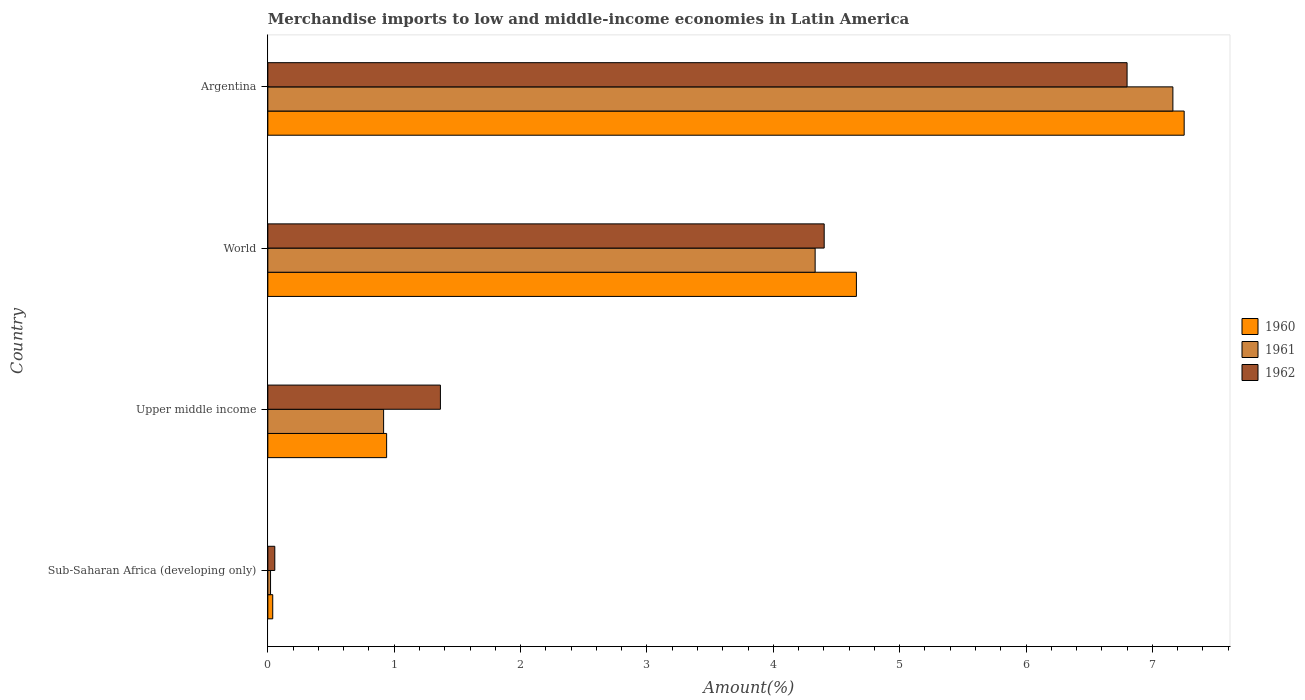How many groups of bars are there?
Offer a terse response. 4. Are the number of bars per tick equal to the number of legend labels?
Make the answer very short. Yes. How many bars are there on the 3rd tick from the top?
Provide a succinct answer. 3. What is the label of the 1st group of bars from the top?
Your answer should be very brief. Argentina. In how many cases, is the number of bars for a given country not equal to the number of legend labels?
Give a very brief answer. 0. What is the percentage of amount earned from merchandise imports in 1961 in Sub-Saharan Africa (developing only)?
Make the answer very short. 0.02. Across all countries, what is the maximum percentage of amount earned from merchandise imports in 1960?
Your answer should be very brief. 7.25. Across all countries, what is the minimum percentage of amount earned from merchandise imports in 1960?
Offer a terse response. 0.04. In which country was the percentage of amount earned from merchandise imports in 1961 maximum?
Provide a succinct answer. Argentina. In which country was the percentage of amount earned from merchandise imports in 1960 minimum?
Your answer should be compact. Sub-Saharan Africa (developing only). What is the total percentage of amount earned from merchandise imports in 1960 in the graph?
Give a very brief answer. 12.89. What is the difference between the percentage of amount earned from merchandise imports in 1960 in Sub-Saharan Africa (developing only) and that in Upper middle income?
Provide a succinct answer. -0.9. What is the difference between the percentage of amount earned from merchandise imports in 1962 in Argentina and the percentage of amount earned from merchandise imports in 1961 in Sub-Saharan Africa (developing only)?
Keep it short and to the point. 6.78. What is the average percentage of amount earned from merchandise imports in 1961 per country?
Your response must be concise. 3.11. What is the difference between the percentage of amount earned from merchandise imports in 1961 and percentage of amount earned from merchandise imports in 1962 in Upper middle income?
Provide a short and direct response. -0.45. In how many countries, is the percentage of amount earned from merchandise imports in 1961 greater than 1.2 %?
Offer a terse response. 2. What is the ratio of the percentage of amount earned from merchandise imports in 1961 in Sub-Saharan Africa (developing only) to that in Upper middle income?
Provide a succinct answer. 0.02. Is the difference between the percentage of amount earned from merchandise imports in 1961 in Argentina and World greater than the difference between the percentage of amount earned from merchandise imports in 1962 in Argentina and World?
Provide a short and direct response. Yes. What is the difference between the highest and the second highest percentage of amount earned from merchandise imports in 1961?
Your answer should be very brief. 2.83. What is the difference between the highest and the lowest percentage of amount earned from merchandise imports in 1962?
Offer a terse response. 6.74. In how many countries, is the percentage of amount earned from merchandise imports in 1962 greater than the average percentage of amount earned from merchandise imports in 1962 taken over all countries?
Give a very brief answer. 2. What does the 3rd bar from the bottom in Argentina represents?
Provide a succinct answer. 1962. How many bars are there?
Make the answer very short. 12. How many countries are there in the graph?
Your answer should be very brief. 4. What is the difference between two consecutive major ticks on the X-axis?
Your answer should be compact. 1. Does the graph contain grids?
Make the answer very short. No. How many legend labels are there?
Your answer should be very brief. 3. How are the legend labels stacked?
Your answer should be compact. Vertical. What is the title of the graph?
Make the answer very short. Merchandise imports to low and middle-income economies in Latin America. What is the label or title of the X-axis?
Your answer should be very brief. Amount(%). What is the label or title of the Y-axis?
Give a very brief answer. Country. What is the Amount(%) of 1960 in Sub-Saharan Africa (developing only)?
Keep it short and to the point. 0.04. What is the Amount(%) of 1961 in Sub-Saharan Africa (developing only)?
Ensure brevity in your answer.  0.02. What is the Amount(%) in 1962 in Sub-Saharan Africa (developing only)?
Your answer should be very brief. 0.06. What is the Amount(%) in 1960 in Upper middle income?
Keep it short and to the point. 0.94. What is the Amount(%) in 1961 in Upper middle income?
Offer a very short reply. 0.92. What is the Amount(%) in 1962 in Upper middle income?
Your response must be concise. 1.37. What is the Amount(%) in 1960 in World?
Provide a short and direct response. 4.66. What is the Amount(%) of 1961 in World?
Provide a short and direct response. 4.33. What is the Amount(%) of 1962 in World?
Provide a short and direct response. 4.4. What is the Amount(%) in 1960 in Argentina?
Provide a short and direct response. 7.25. What is the Amount(%) in 1961 in Argentina?
Give a very brief answer. 7.16. What is the Amount(%) of 1962 in Argentina?
Provide a short and direct response. 6.8. Across all countries, what is the maximum Amount(%) in 1960?
Ensure brevity in your answer.  7.25. Across all countries, what is the maximum Amount(%) of 1961?
Ensure brevity in your answer.  7.16. Across all countries, what is the maximum Amount(%) in 1962?
Your response must be concise. 6.8. Across all countries, what is the minimum Amount(%) of 1960?
Offer a very short reply. 0.04. Across all countries, what is the minimum Amount(%) in 1961?
Ensure brevity in your answer.  0.02. Across all countries, what is the minimum Amount(%) in 1962?
Provide a succinct answer. 0.06. What is the total Amount(%) in 1960 in the graph?
Give a very brief answer. 12.89. What is the total Amount(%) of 1961 in the graph?
Offer a very short reply. 12.43. What is the total Amount(%) in 1962 in the graph?
Your answer should be very brief. 12.62. What is the difference between the Amount(%) of 1960 in Sub-Saharan Africa (developing only) and that in Upper middle income?
Provide a short and direct response. -0.9. What is the difference between the Amount(%) in 1961 in Sub-Saharan Africa (developing only) and that in Upper middle income?
Provide a succinct answer. -0.89. What is the difference between the Amount(%) of 1962 in Sub-Saharan Africa (developing only) and that in Upper middle income?
Your response must be concise. -1.31. What is the difference between the Amount(%) in 1960 in Sub-Saharan Africa (developing only) and that in World?
Your answer should be very brief. -4.62. What is the difference between the Amount(%) of 1961 in Sub-Saharan Africa (developing only) and that in World?
Your answer should be very brief. -4.31. What is the difference between the Amount(%) in 1962 in Sub-Saharan Africa (developing only) and that in World?
Your answer should be very brief. -4.35. What is the difference between the Amount(%) in 1960 in Sub-Saharan Africa (developing only) and that in Argentina?
Give a very brief answer. -7.21. What is the difference between the Amount(%) of 1961 in Sub-Saharan Africa (developing only) and that in Argentina?
Make the answer very short. -7.14. What is the difference between the Amount(%) in 1962 in Sub-Saharan Africa (developing only) and that in Argentina?
Offer a very short reply. -6.74. What is the difference between the Amount(%) in 1960 in Upper middle income and that in World?
Keep it short and to the point. -3.72. What is the difference between the Amount(%) in 1961 in Upper middle income and that in World?
Your answer should be compact. -3.42. What is the difference between the Amount(%) of 1962 in Upper middle income and that in World?
Offer a terse response. -3.04. What is the difference between the Amount(%) in 1960 in Upper middle income and that in Argentina?
Provide a short and direct response. -6.31. What is the difference between the Amount(%) of 1961 in Upper middle income and that in Argentina?
Ensure brevity in your answer.  -6.25. What is the difference between the Amount(%) of 1962 in Upper middle income and that in Argentina?
Offer a terse response. -5.43. What is the difference between the Amount(%) in 1960 in World and that in Argentina?
Provide a succinct answer. -2.59. What is the difference between the Amount(%) in 1961 in World and that in Argentina?
Your response must be concise. -2.83. What is the difference between the Amount(%) of 1962 in World and that in Argentina?
Keep it short and to the point. -2.4. What is the difference between the Amount(%) of 1960 in Sub-Saharan Africa (developing only) and the Amount(%) of 1961 in Upper middle income?
Make the answer very short. -0.88. What is the difference between the Amount(%) in 1960 in Sub-Saharan Africa (developing only) and the Amount(%) in 1962 in Upper middle income?
Give a very brief answer. -1.33. What is the difference between the Amount(%) in 1961 in Sub-Saharan Africa (developing only) and the Amount(%) in 1962 in Upper middle income?
Offer a terse response. -1.34. What is the difference between the Amount(%) in 1960 in Sub-Saharan Africa (developing only) and the Amount(%) in 1961 in World?
Give a very brief answer. -4.29. What is the difference between the Amount(%) of 1960 in Sub-Saharan Africa (developing only) and the Amount(%) of 1962 in World?
Your response must be concise. -4.36. What is the difference between the Amount(%) in 1961 in Sub-Saharan Africa (developing only) and the Amount(%) in 1962 in World?
Give a very brief answer. -4.38. What is the difference between the Amount(%) of 1960 in Sub-Saharan Africa (developing only) and the Amount(%) of 1961 in Argentina?
Your response must be concise. -7.12. What is the difference between the Amount(%) in 1960 in Sub-Saharan Africa (developing only) and the Amount(%) in 1962 in Argentina?
Offer a very short reply. -6.76. What is the difference between the Amount(%) of 1961 in Sub-Saharan Africa (developing only) and the Amount(%) of 1962 in Argentina?
Provide a succinct answer. -6.78. What is the difference between the Amount(%) of 1960 in Upper middle income and the Amount(%) of 1961 in World?
Offer a terse response. -3.39. What is the difference between the Amount(%) of 1960 in Upper middle income and the Amount(%) of 1962 in World?
Keep it short and to the point. -3.46. What is the difference between the Amount(%) of 1961 in Upper middle income and the Amount(%) of 1962 in World?
Offer a very short reply. -3.49. What is the difference between the Amount(%) of 1960 in Upper middle income and the Amount(%) of 1961 in Argentina?
Your answer should be compact. -6.22. What is the difference between the Amount(%) of 1960 in Upper middle income and the Amount(%) of 1962 in Argentina?
Make the answer very short. -5.86. What is the difference between the Amount(%) in 1961 in Upper middle income and the Amount(%) in 1962 in Argentina?
Provide a succinct answer. -5.88. What is the difference between the Amount(%) of 1960 in World and the Amount(%) of 1961 in Argentina?
Your response must be concise. -2.5. What is the difference between the Amount(%) of 1960 in World and the Amount(%) of 1962 in Argentina?
Provide a succinct answer. -2.14. What is the difference between the Amount(%) in 1961 in World and the Amount(%) in 1962 in Argentina?
Provide a succinct answer. -2.47. What is the average Amount(%) in 1960 per country?
Give a very brief answer. 3.22. What is the average Amount(%) in 1961 per country?
Ensure brevity in your answer.  3.11. What is the average Amount(%) in 1962 per country?
Provide a succinct answer. 3.16. What is the difference between the Amount(%) of 1960 and Amount(%) of 1961 in Sub-Saharan Africa (developing only)?
Offer a terse response. 0.02. What is the difference between the Amount(%) of 1960 and Amount(%) of 1962 in Sub-Saharan Africa (developing only)?
Provide a short and direct response. -0.02. What is the difference between the Amount(%) of 1961 and Amount(%) of 1962 in Sub-Saharan Africa (developing only)?
Provide a succinct answer. -0.03. What is the difference between the Amount(%) of 1960 and Amount(%) of 1961 in Upper middle income?
Ensure brevity in your answer.  0.02. What is the difference between the Amount(%) in 1960 and Amount(%) in 1962 in Upper middle income?
Make the answer very short. -0.43. What is the difference between the Amount(%) in 1961 and Amount(%) in 1962 in Upper middle income?
Your answer should be compact. -0.45. What is the difference between the Amount(%) of 1960 and Amount(%) of 1961 in World?
Make the answer very short. 0.33. What is the difference between the Amount(%) in 1960 and Amount(%) in 1962 in World?
Make the answer very short. 0.26. What is the difference between the Amount(%) in 1961 and Amount(%) in 1962 in World?
Your answer should be very brief. -0.07. What is the difference between the Amount(%) in 1960 and Amount(%) in 1961 in Argentina?
Provide a short and direct response. 0.09. What is the difference between the Amount(%) of 1960 and Amount(%) of 1962 in Argentina?
Make the answer very short. 0.45. What is the difference between the Amount(%) of 1961 and Amount(%) of 1962 in Argentina?
Provide a succinct answer. 0.36. What is the ratio of the Amount(%) of 1960 in Sub-Saharan Africa (developing only) to that in Upper middle income?
Make the answer very short. 0.04. What is the ratio of the Amount(%) in 1961 in Sub-Saharan Africa (developing only) to that in Upper middle income?
Your response must be concise. 0.02. What is the ratio of the Amount(%) in 1962 in Sub-Saharan Africa (developing only) to that in Upper middle income?
Offer a terse response. 0.04. What is the ratio of the Amount(%) in 1960 in Sub-Saharan Africa (developing only) to that in World?
Give a very brief answer. 0.01. What is the ratio of the Amount(%) in 1961 in Sub-Saharan Africa (developing only) to that in World?
Offer a terse response. 0. What is the ratio of the Amount(%) of 1962 in Sub-Saharan Africa (developing only) to that in World?
Make the answer very short. 0.01. What is the ratio of the Amount(%) of 1960 in Sub-Saharan Africa (developing only) to that in Argentina?
Provide a succinct answer. 0.01. What is the ratio of the Amount(%) in 1961 in Sub-Saharan Africa (developing only) to that in Argentina?
Make the answer very short. 0. What is the ratio of the Amount(%) in 1962 in Sub-Saharan Africa (developing only) to that in Argentina?
Ensure brevity in your answer.  0.01. What is the ratio of the Amount(%) of 1960 in Upper middle income to that in World?
Provide a short and direct response. 0.2. What is the ratio of the Amount(%) in 1961 in Upper middle income to that in World?
Offer a very short reply. 0.21. What is the ratio of the Amount(%) of 1962 in Upper middle income to that in World?
Provide a short and direct response. 0.31. What is the ratio of the Amount(%) in 1960 in Upper middle income to that in Argentina?
Offer a very short reply. 0.13. What is the ratio of the Amount(%) of 1961 in Upper middle income to that in Argentina?
Keep it short and to the point. 0.13. What is the ratio of the Amount(%) of 1962 in Upper middle income to that in Argentina?
Offer a terse response. 0.2. What is the ratio of the Amount(%) of 1960 in World to that in Argentina?
Provide a short and direct response. 0.64. What is the ratio of the Amount(%) in 1961 in World to that in Argentina?
Offer a terse response. 0.6. What is the ratio of the Amount(%) of 1962 in World to that in Argentina?
Give a very brief answer. 0.65. What is the difference between the highest and the second highest Amount(%) of 1960?
Your response must be concise. 2.59. What is the difference between the highest and the second highest Amount(%) in 1961?
Provide a succinct answer. 2.83. What is the difference between the highest and the second highest Amount(%) of 1962?
Your response must be concise. 2.4. What is the difference between the highest and the lowest Amount(%) of 1960?
Offer a very short reply. 7.21. What is the difference between the highest and the lowest Amount(%) of 1961?
Ensure brevity in your answer.  7.14. What is the difference between the highest and the lowest Amount(%) of 1962?
Keep it short and to the point. 6.74. 